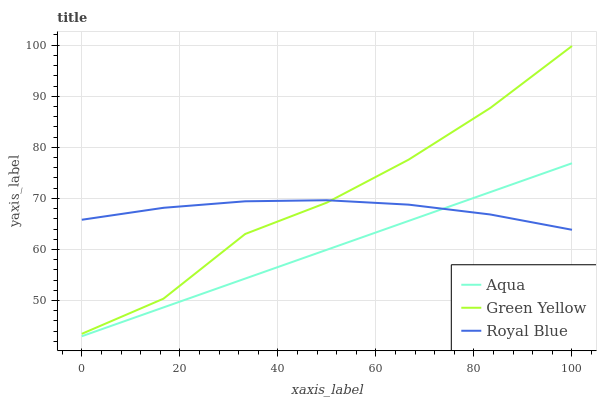Does Aqua have the minimum area under the curve?
Answer yes or no. Yes. Does Green Yellow have the maximum area under the curve?
Answer yes or no. Yes. Does Green Yellow have the minimum area under the curve?
Answer yes or no. No. Does Aqua have the maximum area under the curve?
Answer yes or no. No. Is Aqua the smoothest?
Answer yes or no. Yes. Is Green Yellow the roughest?
Answer yes or no. Yes. Is Green Yellow the smoothest?
Answer yes or no. No. Is Aqua the roughest?
Answer yes or no. No. Does Green Yellow have the lowest value?
Answer yes or no. No. Does Green Yellow have the highest value?
Answer yes or no. Yes. Does Aqua have the highest value?
Answer yes or no. No. Is Aqua less than Green Yellow?
Answer yes or no. Yes. Is Green Yellow greater than Aqua?
Answer yes or no. Yes. Does Aqua intersect Royal Blue?
Answer yes or no. Yes. Is Aqua less than Royal Blue?
Answer yes or no. No. Is Aqua greater than Royal Blue?
Answer yes or no. No. Does Aqua intersect Green Yellow?
Answer yes or no. No. 